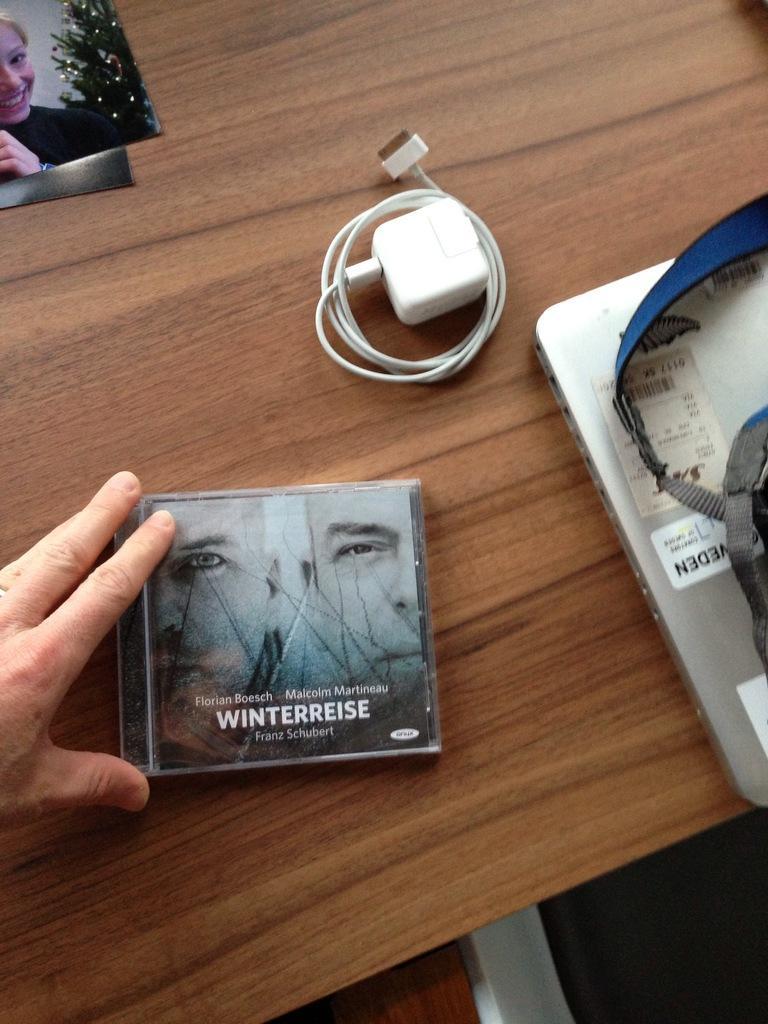How would you summarize this image in a sentence or two? As we can see in the image there is a table. On table there is a laptop, bag, changer and a photo. 